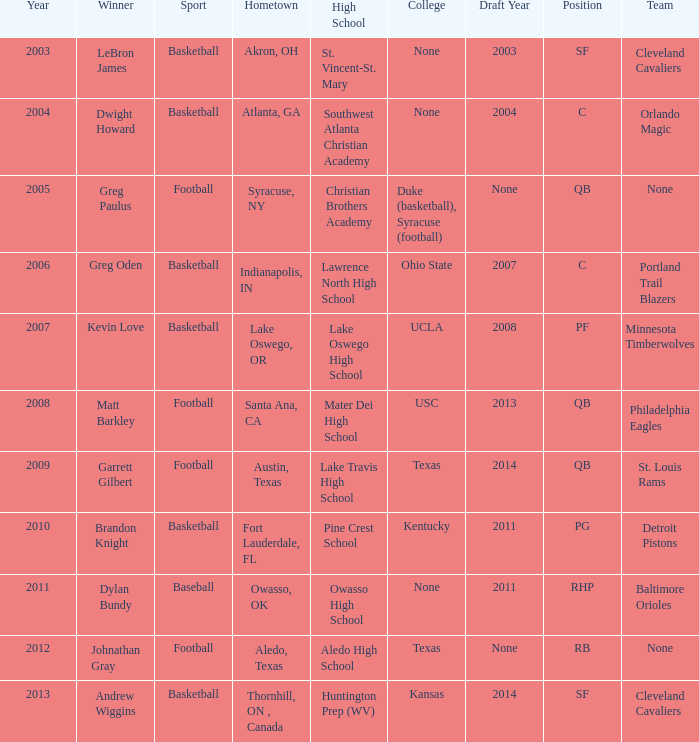What is Hometown, when Sport is "Basketball", and when Winner is "Dwight Howard"? Atlanta, GA. 